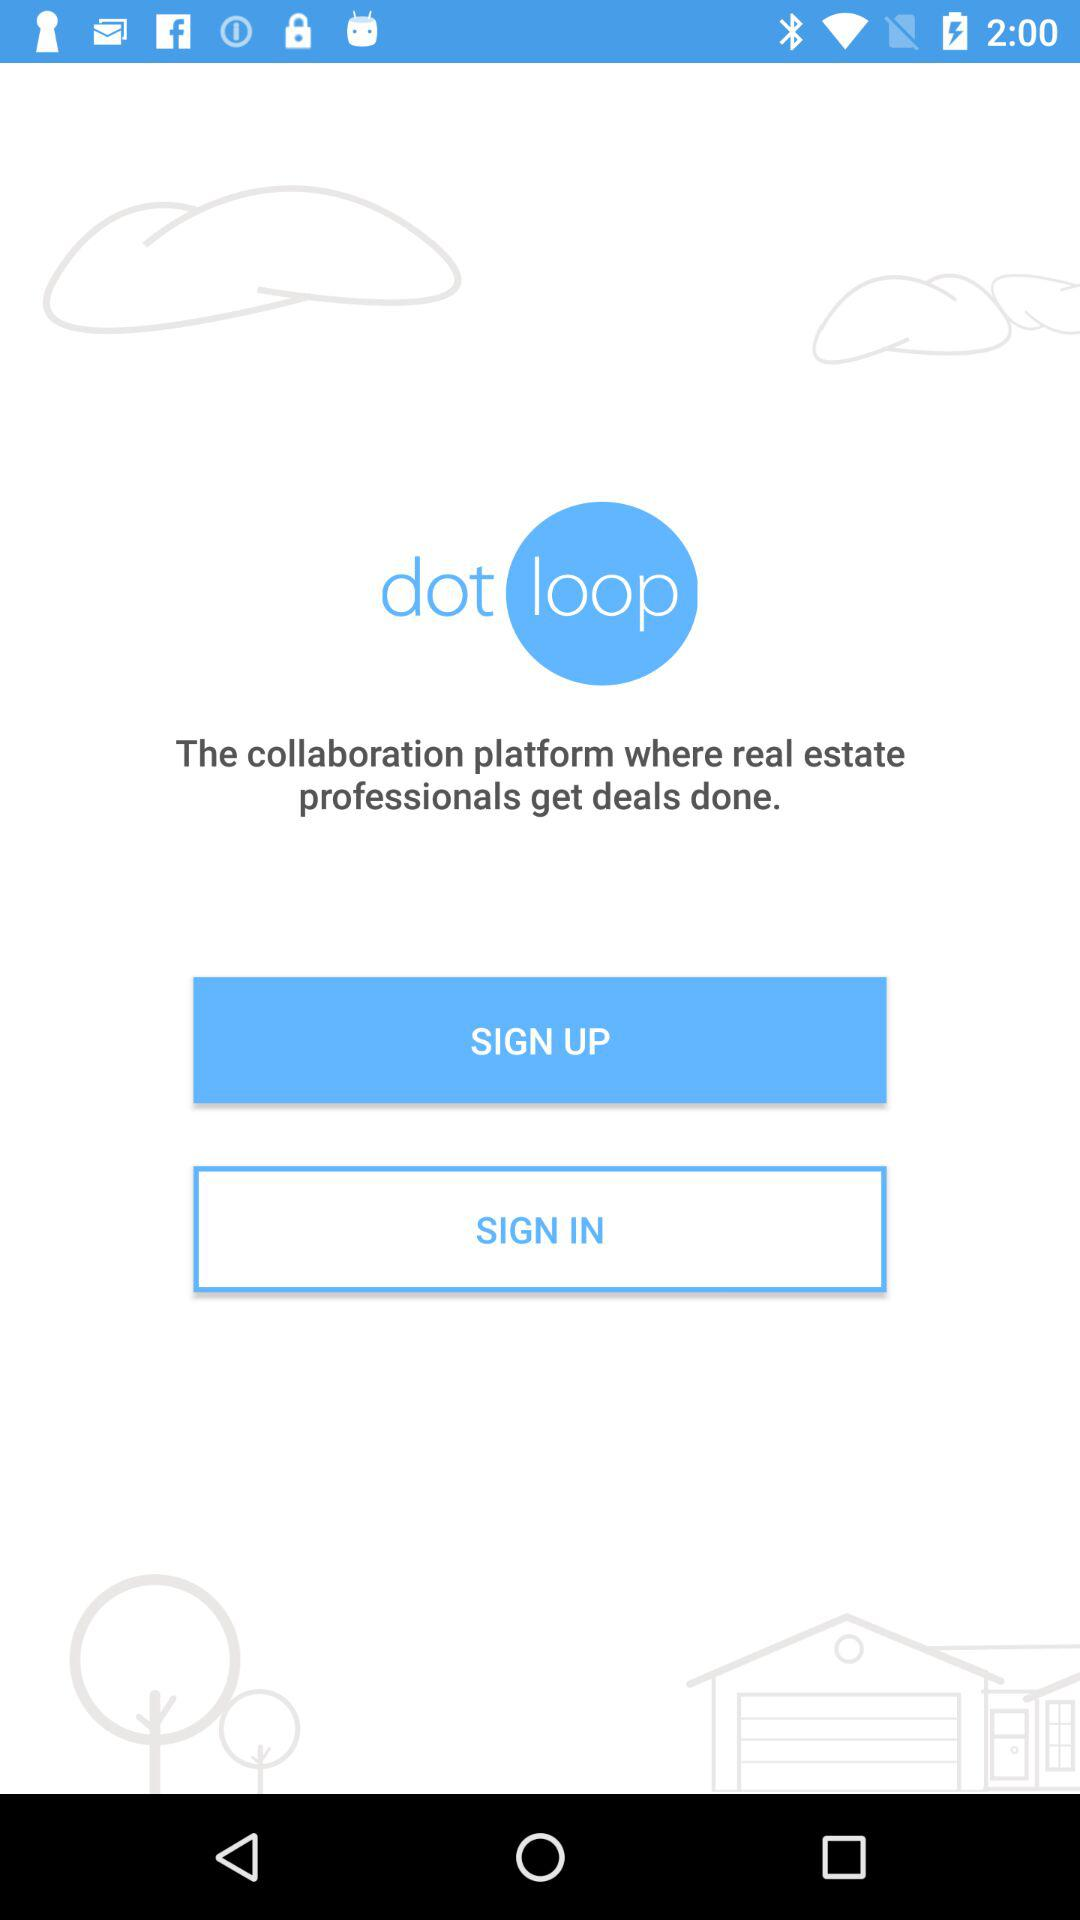How many real estate professionals get deals done using "dotloop"?
When the provided information is insufficient, respond with <no answer>. <no answer> 